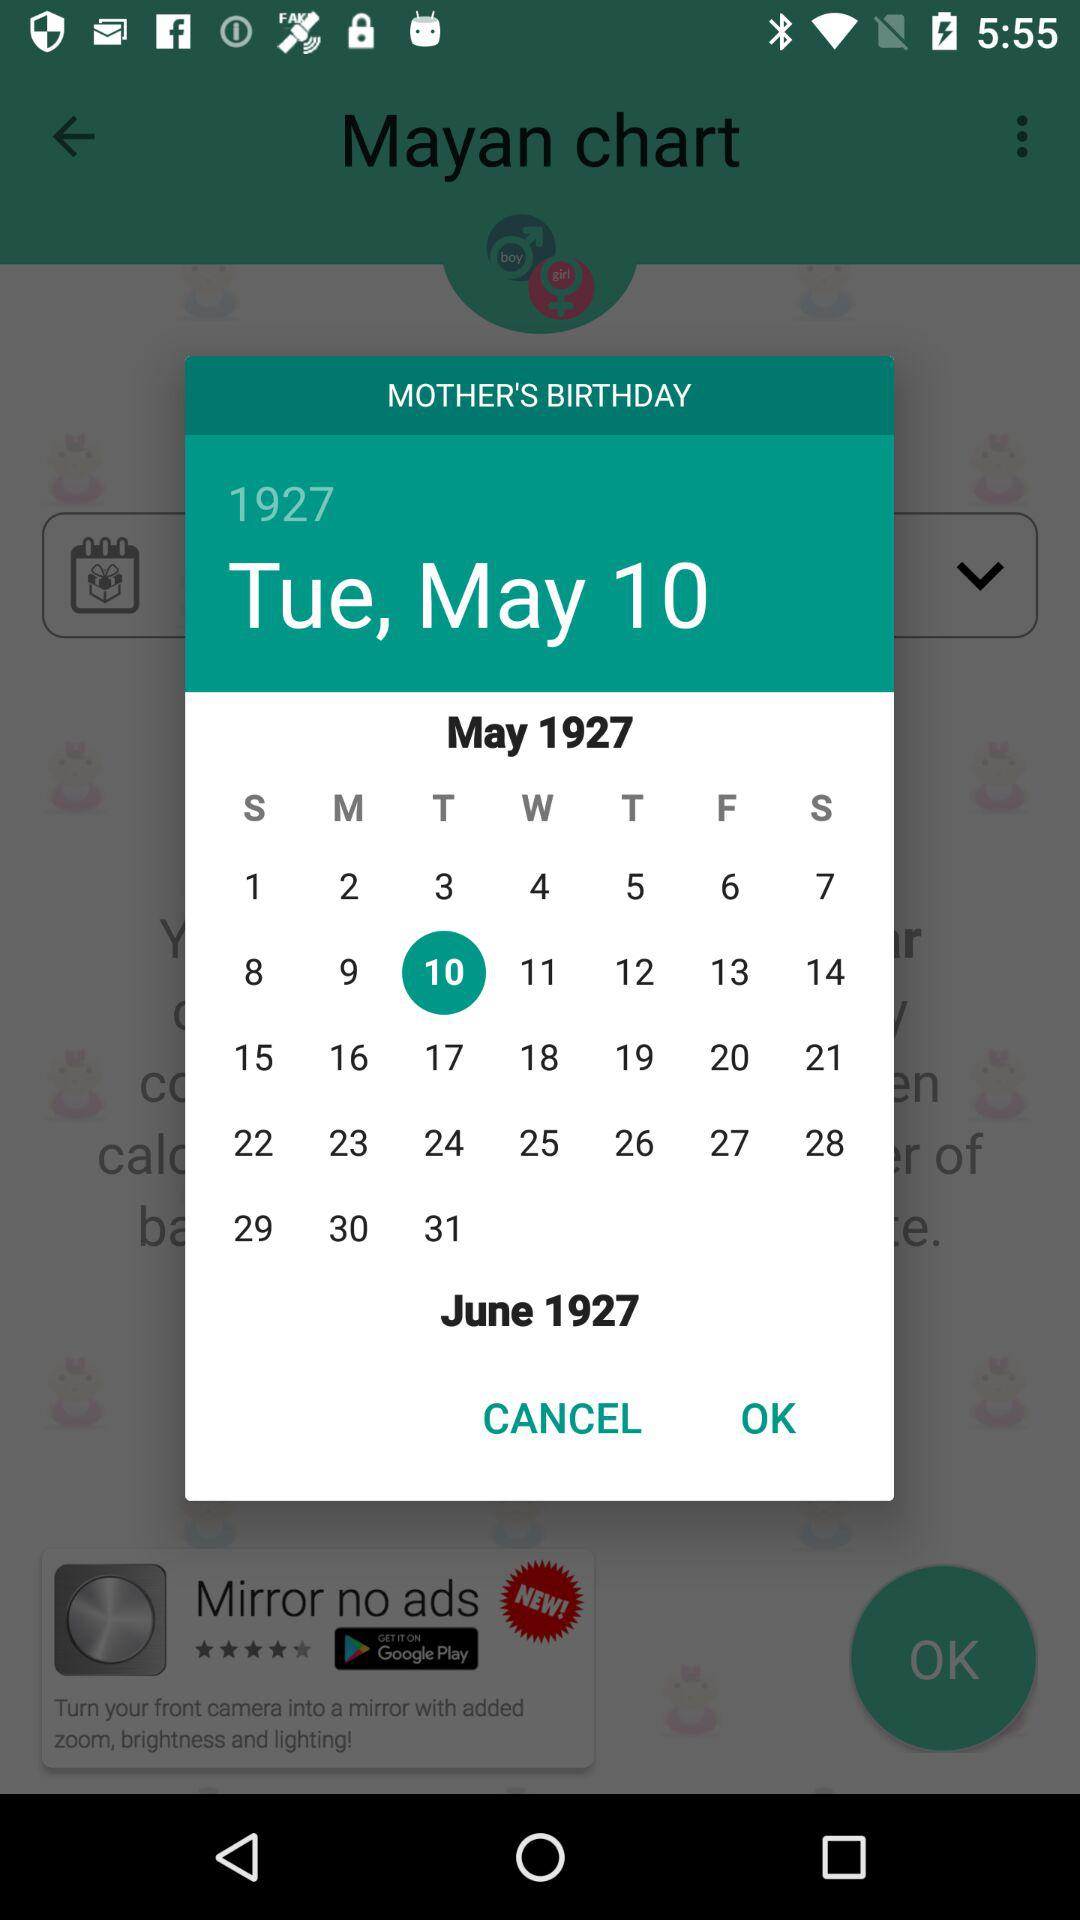What is the selected date? The selected date is Tuesday, May 10, 1927. 